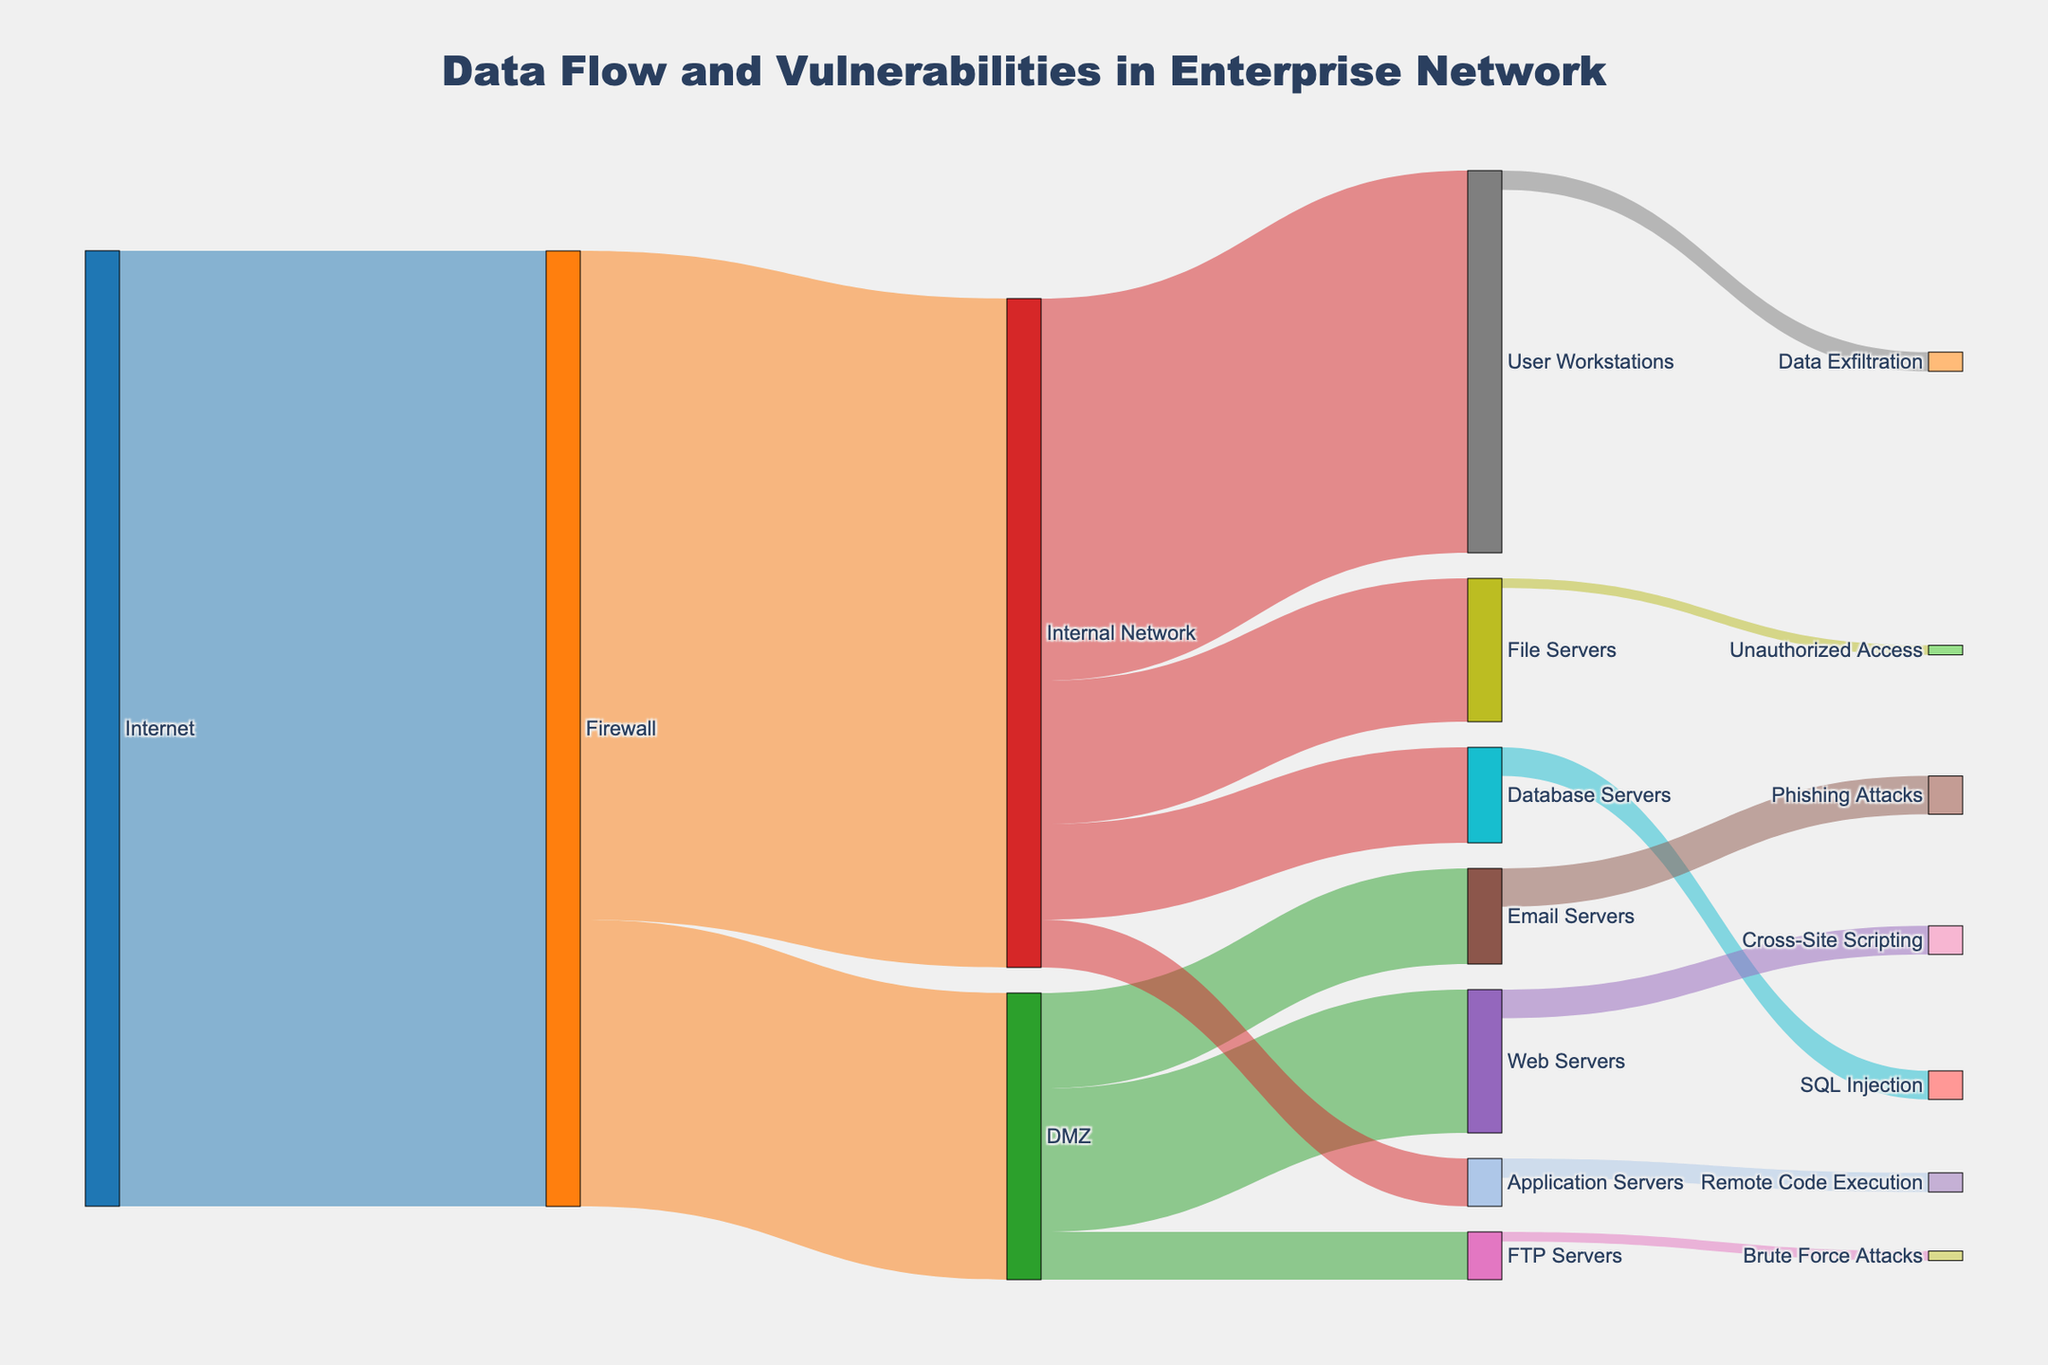What's the data flow from the Internet to the Internal Network? The Sankey diagram shows that data flows from the Internet to the Firewall with a value of 100. From the Firewall, 70 units of data flow to the Internal Network.
Answer: 70 Which element receives the highest data flow from the Firewall? The Firewall directs 70 units of data to the Internal Network and 30 units to the DMZ. By comparing these values, the Internal Network receives the highest data flow.
Answer: Internal Network How much data flow goes to the Web Servers and Email Servers combined? The Sankey diagram shows 15 units of data flowing to the Web Servers and 10 units to the Email Servers. Adding these values gives a combined flow of 25.
Answer: 25 What is the total data flow into the User Workstations and File Servers? The Internal Network sends 40 units of data to User Workstations and 15 units to File Servers. Adding these values gives a total flow of 55 units.
Answer: 55 What is the difference between the data flow from the Firewall to the DMZ and the Firewall to the Internal Network? The Firewall directs 70 units of data to the Internal Network and 30 units to the DMZ. The difference between these values is 40 units.
Answer: 40 Which pathway involves a security vulnerability of SQL Injection? The Sankey diagram shows that SQL Injection is a vulnerability associated with the Database Servers within the Internal Network.
Answer: Database Servers Comparing Phishing Attacks and Cross-Site Scripting, which has a higher risk based on data flow? Phishing Attacks have a value of 4 units linked to Email Servers, while Cross-Site Scripting has 3 units linked to Web Servers. Thus, Phishing Attacks have a higher risk based on data flow.
Answer: Phishing Attacks What is the total data inflow into the DMZ? The only connection into the DMZ is from the Firewall with a data flow of 30 units.
Answer: 30 